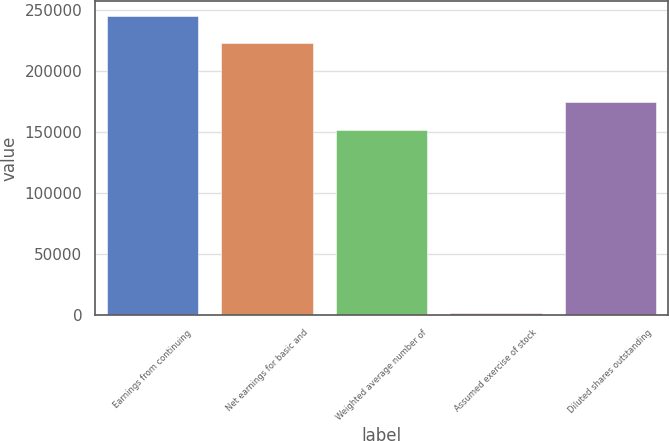Convert chart to OTSL. <chart><loc_0><loc_0><loc_500><loc_500><bar_chart><fcel>Earnings from continuing<fcel>Net earnings for basic and<fcel>Weighted average number of<fcel>Assumed exercise of stock<fcel>Diluted shares outstanding<nl><fcel>244738<fcel>222398<fcel>151634<fcel>1960<fcel>173974<nl></chart> 